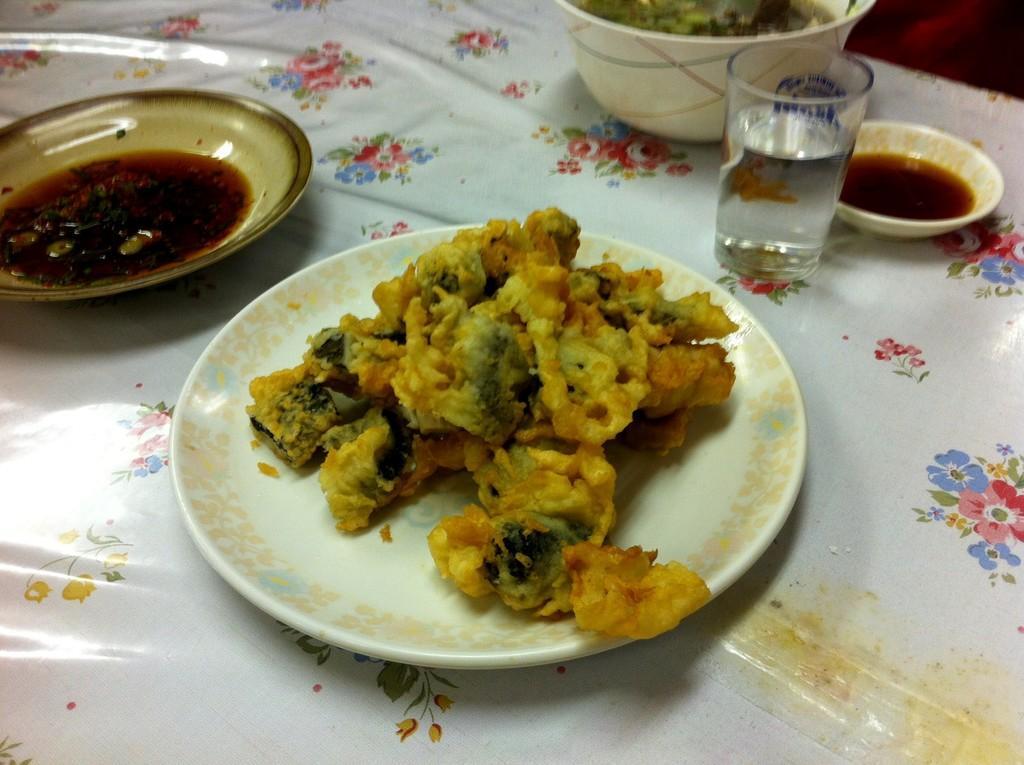In one or two sentences, can you explain what this image depicts? In this picture we can see a table at the bottom, there are two plates, two bowls and a glass of drink present on the table, we can see some food in these plates and bowls. 